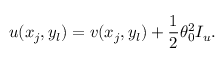Convert formula to latex. <formula><loc_0><loc_0><loc_500><loc_500>u ( x _ { j } , y _ { l } ) = v ( x _ { j } , y _ { l } ) + \frac { 1 } { 2 } \theta _ { 0 } ^ { 2 } I _ { u } .</formula> 